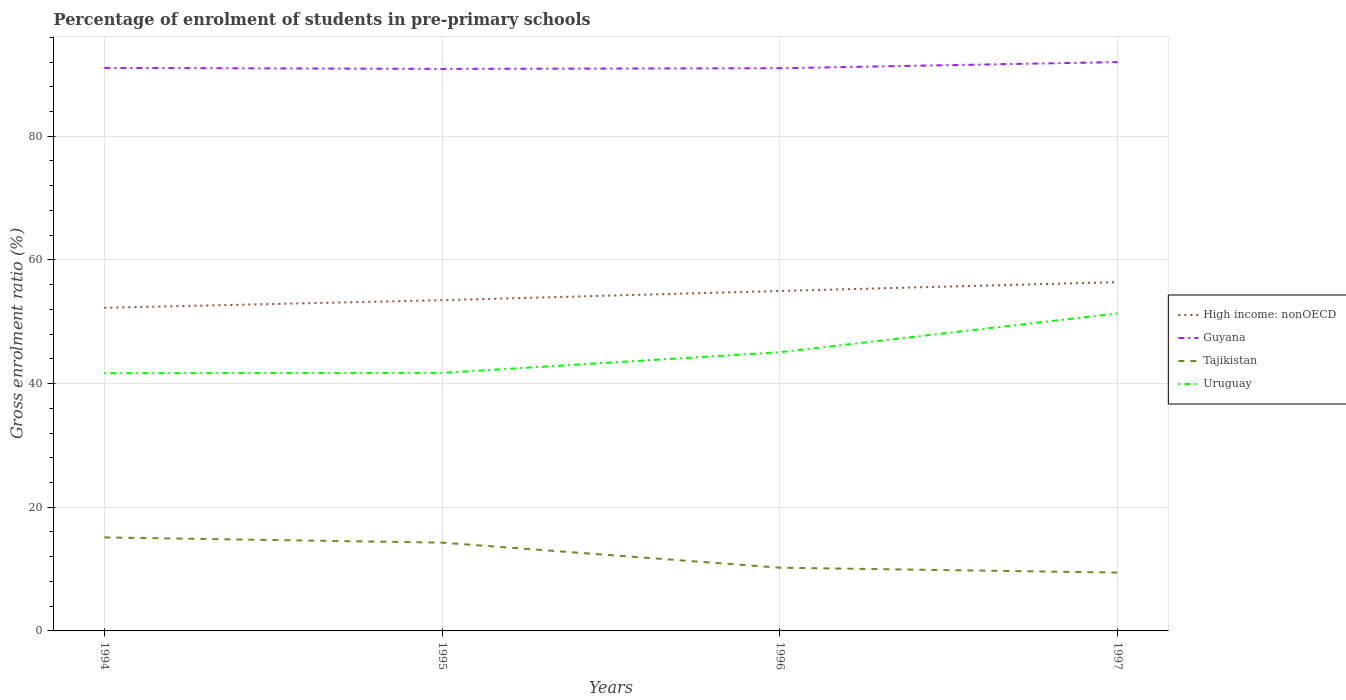How many different coloured lines are there?
Ensure brevity in your answer.  4. Is the number of lines equal to the number of legend labels?
Offer a terse response. Yes. Across all years, what is the maximum percentage of students enrolled in pre-primary schools in Tajikistan?
Offer a terse response. 9.44. In which year was the percentage of students enrolled in pre-primary schools in Tajikistan maximum?
Give a very brief answer. 1997. What is the total percentage of students enrolled in pre-primary schools in Tajikistan in the graph?
Provide a succinct answer. 0.79. What is the difference between the highest and the second highest percentage of students enrolled in pre-primary schools in Tajikistan?
Provide a succinct answer. 5.69. What is the difference between the highest and the lowest percentage of students enrolled in pre-primary schools in Tajikistan?
Keep it short and to the point. 2. Is the percentage of students enrolled in pre-primary schools in Uruguay strictly greater than the percentage of students enrolled in pre-primary schools in High income: nonOECD over the years?
Your answer should be compact. Yes. Are the values on the major ticks of Y-axis written in scientific E-notation?
Your response must be concise. No. Does the graph contain any zero values?
Ensure brevity in your answer.  No. Does the graph contain grids?
Your answer should be compact. Yes. Where does the legend appear in the graph?
Offer a terse response. Center right. How are the legend labels stacked?
Make the answer very short. Vertical. What is the title of the graph?
Give a very brief answer. Percentage of enrolment of students in pre-primary schools. Does "Central Europe" appear as one of the legend labels in the graph?
Offer a terse response. No. What is the label or title of the X-axis?
Ensure brevity in your answer.  Years. What is the label or title of the Y-axis?
Provide a succinct answer. Gross enrolment ratio (%). What is the Gross enrolment ratio (%) of High income: nonOECD in 1994?
Offer a very short reply. 52.26. What is the Gross enrolment ratio (%) in Guyana in 1994?
Ensure brevity in your answer.  91.05. What is the Gross enrolment ratio (%) in Tajikistan in 1994?
Offer a terse response. 15.12. What is the Gross enrolment ratio (%) of Uruguay in 1994?
Ensure brevity in your answer.  41.68. What is the Gross enrolment ratio (%) in High income: nonOECD in 1995?
Your answer should be very brief. 53.49. What is the Gross enrolment ratio (%) in Guyana in 1995?
Offer a terse response. 90.89. What is the Gross enrolment ratio (%) of Tajikistan in 1995?
Your answer should be very brief. 14.28. What is the Gross enrolment ratio (%) in Uruguay in 1995?
Give a very brief answer. 41.73. What is the Gross enrolment ratio (%) in High income: nonOECD in 1996?
Make the answer very short. 54.98. What is the Gross enrolment ratio (%) in Guyana in 1996?
Keep it short and to the point. 91. What is the Gross enrolment ratio (%) in Tajikistan in 1996?
Keep it short and to the point. 10.22. What is the Gross enrolment ratio (%) in Uruguay in 1996?
Keep it short and to the point. 45.07. What is the Gross enrolment ratio (%) of High income: nonOECD in 1997?
Make the answer very short. 56.41. What is the Gross enrolment ratio (%) in Guyana in 1997?
Ensure brevity in your answer.  91.99. What is the Gross enrolment ratio (%) of Tajikistan in 1997?
Ensure brevity in your answer.  9.44. What is the Gross enrolment ratio (%) in Uruguay in 1997?
Offer a very short reply. 51.34. Across all years, what is the maximum Gross enrolment ratio (%) of High income: nonOECD?
Make the answer very short. 56.41. Across all years, what is the maximum Gross enrolment ratio (%) of Guyana?
Provide a succinct answer. 91.99. Across all years, what is the maximum Gross enrolment ratio (%) in Tajikistan?
Offer a terse response. 15.12. Across all years, what is the maximum Gross enrolment ratio (%) of Uruguay?
Provide a short and direct response. 51.34. Across all years, what is the minimum Gross enrolment ratio (%) in High income: nonOECD?
Ensure brevity in your answer.  52.26. Across all years, what is the minimum Gross enrolment ratio (%) of Guyana?
Provide a short and direct response. 90.89. Across all years, what is the minimum Gross enrolment ratio (%) in Tajikistan?
Provide a short and direct response. 9.44. Across all years, what is the minimum Gross enrolment ratio (%) in Uruguay?
Provide a succinct answer. 41.68. What is the total Gross enrolment ratio (%) of High income: nonOECD in the graph?
Ensure brevity in your answer.  217.13. What is the total Gross enrolment ratio (%) in Guyana in the graph?
Ensure brevity in your answer.  364.95. What is the total Gross enrolment ratio (%) of Tajikistan in the graph?
Your answer should be compact. 49.06. What is the total Gross enrolment ratio (%) in Uruguay in the graph?
Ensure brevity in your answer.  179.83. What is the difference between the Gross enrolment ratio (%) in High income: nonOECD in 1994 and that in 1995?
Your response must be concise. -1.23. What is the difference between the Gross enrolment ratio (%) of Guyana in 1994 and that in 1995?
Offer a very short reply. 0.16. What is the difference between the Gross enrolment ratio (%) of Tajikistan in 1994 and that in 1995?
Offer a very short reply. 0.84. What is the difference between the Gross enrolment ratio (%) in Uruguay in 1994 and that in 1995?
Your answer should be very brief. -0.05. What is the difference between the Gross enrolment ratio (%) in High income: nonOECD in 1994 and that in 1996?
Offer a very short reply. -2.72. What is the difference between the Gross enrolment ratio (%) of Guyana in 1994 and that in 1996?
Keep it short and to the point. 0.05. What is the difference between the Gross enrolment ratio (%) in Tajikistan in 1994 and that in 1996?
Your answer should be very brief. 4.9. What is the difference between the Gross enrolment ratio (%) of Uruguay in 1994 and that in 1996?
Provide a succinct answer. -3.39. What is the difference between the Gross enrolment ratio (%) in High income: nonOECD in 1994 and that in 1997?
Offer a terse response. -4.15. What is the difference between the Gross enrolment ratio (%) in Guyana in 1994 and that in 1997?
Ensure brevity in your answer.  -0.94. What is the difference between the Gross enrolment ratio (%) of Tajikistan in 1994 and that in 1997?
Your answer should be compact. 5.69. What is the difference between the Gross enrolment ratio (%) of Uruguay in 1994 and that in 1997?
Give a very brief answer. -9.66. What is the difference between the Gross enrolment ratio (%) of High income: nonOECD in 1995 and that in 1996?
Offer a very short reply. -1.49. What is the difference between the Gross enrolment ratio (%) in Guyana in 1995 and that in 1996?
Offer a very short reply. -0.11. What is the difference between the Gross enrolment ratio (%) in Tajikistan in 1995 and that in 1996?
Your response must be concise. 4.05. What is the difference between the Gross enrolment ratio (%) in Uruguay in 1995 and that in 1996?
Offer a terse response. -3.34. What is the difference between the Gross enrolment ratio (%) of High income: nonOECD in 1995 and that in 1997?
Provide a succinct answer. -2.92. What is the difference between the Gross enrolment ratio (%) in Guyana in 1995 and that in 1997?
Make the answer very short. -1.1. What is the difference between the Gross enrolment ratio (%) of Tajikistan in 1995 and that in 1997?
Provide a succinct answer. 4.84. What is the difference between the Gross enrolment ratio (%) in Uruguay in 1995 and that in 1997?
Give a very brief answer. -9.61. What is the difference between the Gross enrolment ratio (%) in High income: nonOECD in 1996 and that in 1997?
Provide a succinct answer. -1.43. What is the difference between the Gross enrolment ratio (%) in Guyana in 1996 and that in 1997?
Your response must be concise. -0.99. What is the difference between the Gross enrolment ratio (%) of Tajikistan in 1996 and that in 1997?
Your answer should be compact. 0.79. What is the difference between the Gross enrolment ratio (%) in Uruguay in 1996 and that in 1997?
Offer a terse response. -6.27. What is the difference between the Gross enrolment ratio (%) in High income: nonOECD in 1994 and the Gross enrolment ratio (%) in Guyana in 1995?
Your response must be concise. -38.64. What is the difference between the Gross enrolment ratio (%) in High income: nonOECD in 1994 and the Gross enrolment ratio (%) in Tajikistan in 1995?
Make the answer very short. 37.98. What is the difference between the Gross enrolment ratio (%) of High income: nonOECD in 1994 and the Gross enrolment ratio (%) of Uruguay in 1995?
Give a very brief answer. 10.52. What is the difference between the Gross enrolment ratio (%) in Guyana in 1994 and the Gross enrolment ratio (%) in Tajikistan in 1995?
Offer a very short reply. 76.78. What is the difference between the Gross enrolment ratio (%) of Guyana in 1994 and the Gross enrolment ratio (%) of Uruguay in 1995?
Provide a succinct answer. 49.32. What is the difference between the Gross enrolment ratio (%) of Tajikistan in 1994 and the Gross enrolment ratio (%) of Uruguay in 1995?
Keep it short and to the point. -26.61. What is the difference between the Gross enrolment ratio (%) of High income: nonOECD in 1994 and the Gross enrolment ratio (%) of Guyana in 1996?
Your response must be concise. -38.75. What is the difference between the Gross enrolment ratio (%) in High income: nonOECD in 1994 and the Gross enrolment ratio (%) in Tajikistan in 1996?
Provide a succinct answer. 42.03. What is the difference between the Gross enrolment ratio (%) in High income: nonOECD in 1994 and the Gross enrolment ratio (%) in Uruguay in 1996?
Give a very brief answer. 7.18. What is the difference between the Gross enrolment ratio (%) in Guyana in 1994 and the Gross enrolment ratio (%) in Tajikistan in 1996?
Your answer should be compact. 80.83. What is the difference between the Gross enrolment ratio (%) of Guyana in 1994 and the Gross enrolment ratio (%) of Uruguay in 1996?
Provide a succinct answer. 45.98. What is the difference between the Gross enrolment ratio (%) in Tajikistan in 1994 and the Gross enrolment ratio (%) in Uruguay in 1996?
Make the answer very short. -29.95. What is the difference between the Gross enrolment ratio (%) of High income: nonOECD in 1994 and the Gross enrolment ratio (%) of Guyana in 1997?
Your answer should be compact. -39.74. What is the difference between the Gross enrolment ratio (%) in High income: nonOECD in 1994 and the Gross enrolment ratio (%) in Tajikistan in 1997?
Ensure brevity in your answer.  42.82. What is the difference between the Gross enrolment ratio (%) of High income: nonOECD in 1994 and the Gross enrolment ratio (%) of Uruguay in 1997?
Your answer should be very brief. 0.92. What is the difference between the Gross enrolment ratio (%) of Guyana in 1994 and the Gross enrolment ratio (%) of Tajikistan in 1997?
Your answer should be compact. 81.62. What is the difference between the Gross enrolment ratio (%) of Guyana in 1994 and the Gross enrolment ratio (%) of Uruguay in 1997?
Your answer should be compact. 39.71. What is the difference between the Gross enrolment ratio (%) of Tajikistan in 1994 and the Gross enrolment ratio (%) of Uruguay in 1997?
Offer a terse response. -36.22. What is the difference between the Gross enrolment ratio (%) in High income: nonOECD in 1995 and the Gross enrolment ratio (%) in Guyana in 1996?
Provide a succinct answer. -37.52. What is the difference between the Gross enrolment ratio (%) of High income: nonOECD in 1995 and the Gross enrolment ratio (%) of Tajikistan in 1996?
Ensure brevity in your answer.  43.26. What is the difference between the Gross enrolment ratio (%) in High income: nonOECD in 1995 and the Gross enrolment ratio (%) in Uruguay in 1996?
Your answer should be very brief. 8.41. What is the difference between the Gross enrolment ratio (%) in Guyana in 1995 and the Gross enrolment ratio (%) in Tajikistan in 1996?
Your answer should be compact. 80.67. What is the difference between the Gross enrolment ratio (%) in Guyana in 1995 and the Gross enrolment ratio (%) in Uruguay in 1996?
Give a very brief answer. 45.82. What is the difference between the Gross enrolment ratio (%) of Tajikistan in 1995 and the Gross enrolment ratio (%) of Uruguay in 1996?
Offer a very short reply. -30.8. What is the difference between the Gross enrolment ratio (%) of High income: nonOECD in 1995 and the Gross enrolment ratio (%) of Guyana in 1997?
Your answer should be compact. -38.51. What is the difference between the Gross enrolment ratio (%) in High income: nonOECD in 1995 and the Gross enrolment ratio (%) in Tajikistan in 1997?
Offer a terse response. 44.05. What is the difference between the Gross enrolment ratio (%) in High income: nonOECD in 1995 and the Gross enrolment ratio (%) in Uruguay in 1997?
Offer a terse response. 2.15. What is the difference between the Gross enrolment ratio (%) in Guyana in 1995 and the Gross enrolment ratio (%) in Tajikistan in 1997?
Offer a terse response. 81.46. What is the difference between the Gross enrolment ratio (%) in Guyana in 1995 and the Gross enrolment ratio (%) in Uruguay in 1997?
Your answer should be very brief. 39.55. What is the difference between the Gross enrolment ratio (%) of Tajikistan in 1995 and the Gross enrolment ratio (%) of Uruguay in 1997?
Keep it short and to the point. -37.06. What is the difference between the Gross enrolment ratio (%) in High income: nonOECD in 1996 and the Gross enrolment ratio (%) in Guyana in 1997?
Give a very brief answer. -37.01. What is the difference between the Gross enrolment ratio (%) of High income: nonOECD in 1996 and the Gross enrolment ratio (%) of Tajikistan in 1997?
Your response must be concise. 45.54. What is the difference between the Gross enrolment ratio (%) of High income: nonOECD in 1996 and the Gross enrolment ratio (%) of Uruguay in 1997?
Ensure brevity in your answer.  3.64. What is the difference between the Gross enrolment ratio (%) of Guyana in 1996 and the Gross enrolment ratio (%) of Tajikistan in 1997?
Your answer should be very brief. 81.57. What is the difference between the Gross enrolment ratio (%) of Guyana in 1996 and the Gross enrolment ratio (%) of Uruguay in 1997?
Ensure brevity in your answer.  39.66. What is the difference between the Gross enrolment ratio (%) of Tajikistan in 1996 and the Gross enrolment ratio (%) of Uruguay in 1997?
Ensure brevity in your answer.  -41.12. What is the average Gross enrolment ratio (%) in High income: nonOECD per year?
Your answer should be very brief. 54.28. What is the average Gross enrolment ratio (%) of Guyana per year?
Keep it short and to the point. 91.24. What is the average Gross enrolment ratio (%) of Tajikistan per year?
Offer a terse response. 12.27. What is the average Gross enrolment ratio (%) of Uruguay per year?
Offer a terse response. 44.96. In the year 1994, what is the difference between the Gross enrolment ratio (%) of High income: nonOECD and Gross enrolment ratio (%) of Guyana?
Offer a very short reply. -38.8. In the year 1994, what is the difference between the Gross enrolment ratio (%) of High income: nonOECD and Gross enrolment ratio (%) of Tajikistan?
Make the answer very short. 37.13. In the year 1994, what is the difference between the Gross enrolment ratio (%) of High income: nonOECD and Gross enrolment ratio (%) of Uruguay?
Your response must be concise. 10.57. In the year 1994, what is the difference between the Gross enrolment ratio (%) in Guyana and Gross enrolment ratio (%) in Tajikistan?
Give a very brief answer. 75.93. In the year 1994, what is the difference between the Gross enrolment ratio (%) of Guyana and Gross enrolment ratio (%) of Uruguay?
Offer a very short reply. 49.37. In the year 1994, what is the difference between the Gross enrolment ratio (%) in Tajikistan and Gross enrolment ratio (%) in Uruguay?
Keep it short and to the point. -26.56. In the year 1995, what is the difference between the Gross enrolment ratio (%) in High income: nonOECD and Gross enrolment ratio (%) in Guyana?
Your response must be concise. -37.41. In the year 1995, what is the difference between the Gross enrolment ratio (%) of High income: nonOECD and Gross enrolment ratio (%) of Tajikistan?
Offer a terse response. 39.21. In the year 1995, what is the difference between the Gross enrolment ratio (%) of High income: nonOECD and Gross enrolment ratio (%) of Uruguay?
Provide a short and direct response. 11.76. In the year 1995, what is the difference between the Gross enrolment ratio (%) in Guyana and Gross enrolment ratio (%) in Tajikistan?
Keep it short and to the point. 76.61. In the year 1995, what is the difference between the Gross enrolment ratio (%) of Guyana and Gross enrolment ratio (%) of Uruguay?
Make the answer very short. 49.16. In the year 1995, what is the difference between the Gross enrolment ratio (%) of Tajikistan and Gross enrolment ratio (%) of Uruguay?
Provide a short and direct response. -27.45. In the year 1996, what is the difference between the Gross enrolment ratio (%) of High income: nonOECD and Gross enrolment ratio (%) of Guyana?
Give a very brief answer. -36.02. In the year 1996, what is the difference between the Gross enrolment ratio (%) in High income: nonOECD and Gross enrolment ratio (%) in Tajikistan?
Make the answer very short. 44.75. In the year 1996, what is the difference between the Gross enrolment ratio (%) of High income: nonOECD and Gross enrolment ratio (%) of Uruguay?
Your answer should be very brief. 9.91. In the year 1996, what is the difference between the Gross enrolment ratio (%) in Guyana and Gross enrolment ratio (%) in Tajikistan?
Provide a succinct answer. 80.78. In the year 1996, what is the difference between the Gross enrolment ratio (%) of Guyana and Gross enrolment ratio (%) of Uruguay?
Keep it short and to the point. 45.93. In the year 1996, what is the difference between the Gross enrolment ratio (%) of Tajikistan and Gross enrolment ratio (%) of Uruguay?
Your answer should be very brief. -34.85. In the year 1997, what is the difference between the Gross enrolment ratio (%) in High income: nonOECD and Gross enrolment ratio (%) in Guyana?
Ensure brevity in your answer.  -35.58. In the year 1997, what is the difference between the Gross enrolment ratio (%) of High income: nonOECD and Gross enrolment ratio (%) of Tajikistan?
Ensure brevity in your answer.  46.97. In the year 1997, what is the difference between the Gross enrolment ratio (%) of High income: nonOECD and Gross enrolment ratio (%) of Uruguay?
Provide a short and direct response. 5.07. In the year 1997, what is the difference between the Gross enrolment ratio (%) of Guyana and Gross enrolment ratio (%) of Tajikistan?
Make the answer very short. 82.56. In the year 1997, what is the difference between the Gross enrolment ratio (%) in Guyana and Gross enrolment ratio (%) in Uruguay?
Make the answer very short. 40.65. In the year 1997, what is the difference between the Gross enrolment ratio (%) of Tajikistan and Gross enrolment ratio (%) of Uruguay?
Offer a very short reply. -41.9. What is the ratio of the Gross enrolment ratio (%) of Guyana in 1994 to that in 1995?
Give a very brief answer. 1. What is the ratio of the Gross enrolment ratio (%) in Tajikistan in 1994 to that in 1995?
Keep it short and to the point. 1.06. What is the ratio of the Gross enrolment ratio (%) of High income: nonOECD in 1994 to that in 1996?
Your response must be concise. 0.95. What is the ratio of the Gross enrolment ratio (%) in Guyana in 1994 to that in 1996?
Ensure brevity in your answer.  1. What is the ratio of the Gross enrolment ratio (%) in Tajikistan in 1994 to that in 1996?
Make the answer very short. 1.48. What is the ratio of the Gross enrolment ratio (%) in Uruguay in 1994 to that in 1996?
Your answer should be very brief. 0.92. What is the ratio of the Gross enrolment ratio (%) of High income: nonOECD in 1994 to that in 1997?
Offer a terse response. 0.93. What is the ratio of the Gross enrolment ratio (%) in Tajikistan in 1994 to that in 1997?
Offer a terse response. 1.6. What is the ratio of the Gross enrolment ratio (%) in Uruguay in 1994 to that in 1997?
Make the answer very short. 0.81. What is the ratio of the Gross enrolment ratio (%) of High income: nonOECD in 1995 to that in 1996?
Offer a very short reply. 0.97. What is the ratio of the Gross enrolment ratio (%) of Tajikistan in 1995 to that in 1996?
Your answer should be very brief. 1.4. What is the ratio of the Gross enrolment ratio (%) of Uruguay in 1995 to that in 1996?
Ensure brevity in your answer.  0.93. What is the ratio of the Gross enrolment ratio (%) in High income: nonOECD in 1995 to that in 1997?
Your answer should be very brief. 0.95. What is the ratio of the Gross enrolment ratio (%) in Tajikistan in 1995 to that in 1997?
Keep it short and to the point. 1.51. What is the ratio of the Gross enrolment ratio (%) in Uruguay in 1995 to that in 1997?
Offer a terse response. 0.81. What is the ratio of the Gross enrolment ratio (%) of High income: nonOECD in 1996 to that in 1997?
Ensure brevity in your answer.  0.97. What is the ratio of the Gross enrolment ratio (%) of Guyana in 1996 to that in 1997?
Your response must be concise. 0.99. What is the ratio of the Gross enrolment ratio (%) in Tajikistan in 1996 to that in 1997?
Keep it short and to the point. 1.08. What is the ratio of the Gross enrolment ratio (%) of Uruguay in 1996 to that in 1997?
Provide a succinct answer. 0.88. What is the difference between the highest and the second highest Gross enrolment ratio (%) of High income: nonOECD?
Offer a terse response. 1.43. What is the difference between the highest and the second highest Gross enrolment ratio (%) of Guyana?
Ensure brevity in your answer.  0.94. What is the difference between the highest and the second highest Gross enrolment ratio (%) of Tajikistan?
Ensure brevity in your answer.  0.84. What is the difference between the highest and the second highest Gross enrolment ratio (%) in Uruguay?
Provide a succinct answer. 6.27. What is the difference between the highest and the lowest Gross enrolment ratio (%) in High income: nonOECD?
Your answer should be very brief. 4.15. What is the difference between the highest and the lowest Gross enrolment ratio (%) in Guyana?
Offer a very short reply. 1.1. What is the difference between the highest and the lowest Gross enrolment ratio (%) of Tajikistan?
Ensure brevity in your answer.  5.69. What is the difference between the highest and the lowest Gross enrolment ratio (%) of Uruguay?
Offer a terse response. 9.66. 